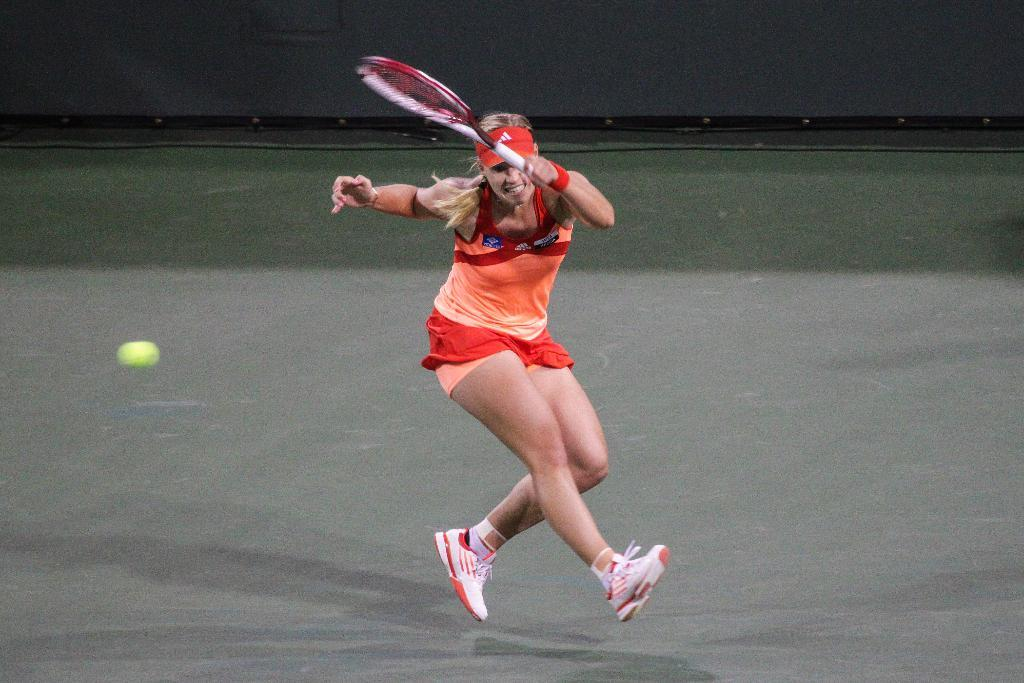What is the main subject of the image? The main subject of the image is a lady person. What is the lady person wearing? The lady person is wearing an orange dress. What activity is the lady person engaged in? The lady person is playing tennis. Reasoning: Let's think step by following the guidelines to produce the conversation. We start by identifying the main subject of the image, which is the lady person. Then, we describe her clothing, mentioning that she is wearing an orange dress. Finally, we focus on her activity, noting that she is playing tennis. Each question is designed to elicit a specific detail about the image that is known from the provided facts. Absurd Question/Answer: What type of industry is depicted in the image? There is no industry depicted in the image; it features a lady person playing tennis. How much tax is being paid by the lady person in the image? There is no mention of tax in the image; it focuses on the lady person playing tennis. 